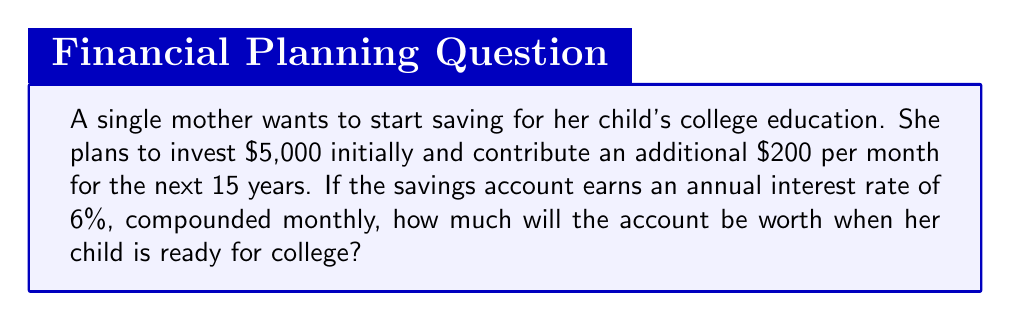Help me with this question. To solve this problem, we'll use the compound interest formula for regular contributions:

$$ A = P(1 + \frac{r}{n})^{nt} + PMT \cdot \frac{(1 + \frac{r}{n})^{nt} - 1}{\frac{r}{n}} $$

Where:
$A$ = Final amount
$P$ = Initial principal balance
$r$ = Annual interest rate (as a decimal)
$n$ = Number of times interest is compounded per year
$t$ = Number of years
$PMT$ = Regular monthly payment

Given:
$P = 5000$
$r = 0.06$ (6% as a decimal)
$n = 12$ (compounded monthly)
$t = 15$ years
$PMT = 200$

Step 1: Calculate the growth of the initial investment:
$$ 5000(1 + \frac{0.06}{12})^{12 \cdot 15} = 5000 \cdot 2.4568 = 12,284 $$

Step 2: Calculate the growth of the regular contributions:
$$ 200 \cdot \frac{(1 + \frac{0.06}{12})^{12 \cdot 15} - 1}{\frac{0.06}{12}} = 200 \cdot 291.3385 = 58,267.70 $$

Step 3: Sum the results from steps 1 and 2:
$$ 12,284 + 58,267.70 = 70,551.70 $$

Therefore, the account will be worth approximately $70,551.70 when the child is ready for college.
Answer: $70,551.70 